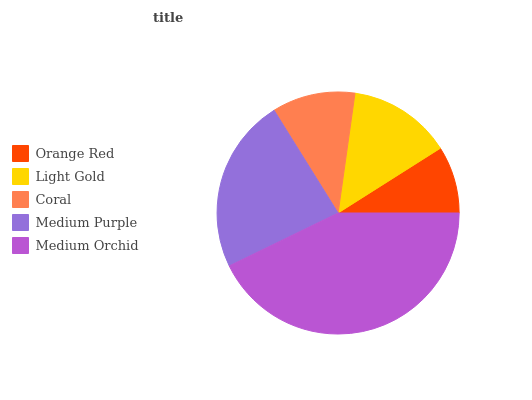Is Orange Red the minimum?
Answer yes or no. Yes. Is Medium Orchid the maximum?
Answer yes or no. Yes. Is Light Gold the minimum?
Answer yes or no. No. Is Light Gold the maximum?
Answer yes or no. No. Is Light Gold greater than Orange Red?
Answer yes or no. Yes. Is Orange Red less than Light Gold?
Answer yes or no. Yes. Is Orange Red greater than Light Gold?
Answer yes or no. No. Is Light Gold less than Orange Red?
Answer yes or no. No. Is Light Gold the high median?
Answer yes or no. Yes. Is Light Gold the low median?
Answer yes or no. Yes. Is Orange Red the high median?
Answer yes or no. No. Is Medium Purple the low median?
Answer yes or no. No. 